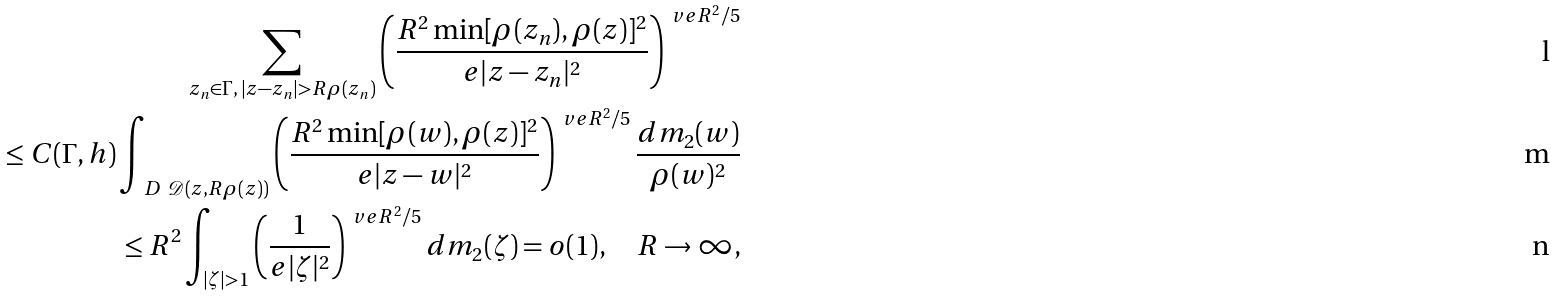Convert formula to latex. <formula><loc_0><loc_0><loc_500><loc_500>\sum _ { z _ { n } \in \Gamma , \, | z - z _ { n } | > R \rho ( z _ { n } ) } \left ( \frac { R ^ { 2 } \min [ \rho ( z _ { n } ) , \rho ( z ) ] ^ { 2 } } { e | z - z _ { n } | ^ { 2 } } \right ) ^ { \ v e R ^ { 2 } / 5 } \\ \leq C ( \Gamma , h ) \int _ { \ D \ \mathcal { D } ( z , R \rho ( z ) ) } \left ( \frac { R ^ { 2 } \min [ \rho ( w ) , \rho ( z ) ] ^ { 2 } } { e | z - w | ^ { 2 } } \right ) ^ { \ v e R ^ { 2 } / 5 } \frac { d m _ { 2 } ( w ) } { \rho ( w ) ^ { 2 } } \\ \leq R ^ { 2 } \int _ { | \zeta | > 1 } \left ( \frac { 1 } { e | \zeta | ^ { 2 } } \right ) ^ { \ v e R ^ { 2 } / 5 } d m _ { 2 } ( \zeta ) = o ( 1 ) , \quad R \to \infty ,</formula> 